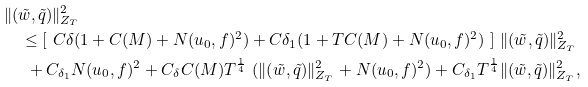Convert formula to latex. <formula><loc_0><loc_0><loc_500><loc_500>& \| ( \tilde { w } , \tilde { q } ) \| ^ { 2 } _ { Z _ { T } } \\ & \quad \leq [ \ C \delta ( 1 + C ( M ) + N ( u _ { 0 } , f ) ^ { 2 } ) + C { \delta _ { 1 } } ( 1 + T C ( M ) + N ( u _ { 0 } , f ) ^ { 2 } ) \ ] \ \| ( \tilde { w } , \tilde { q } ) \| ^ { 2 } _ { Z _ { T } } \\ & \quad \ + C _ { \delta _ { 1 } } N ( u _ { 0 } , f ) ^ { 2 } + C _ { \delta } C ( M ) T ^ { \frac { 1 } { 4 } } \ ( \| ( \tilde { w } , \tilde { q } ) \| ^ { 2 } _ { Z _ { T } } + N ( u _ { 0 } , f ) ^ { 2 } ) + C _ { \delta _ { 1 } } T ^ { \frac { 1 } { 4 } } \| ( \tilde { w } , \tilde { q } ) \| ^ { 2 } _ { Z _ { T } } ,</formula> 